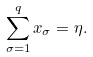Convert formula to latex. <formula><loc_0><loc_0><loc_500><loc_500>\sum _ { \sigma = 1 } ^ { q } x _ { \sigma } = \eta .</formula> 